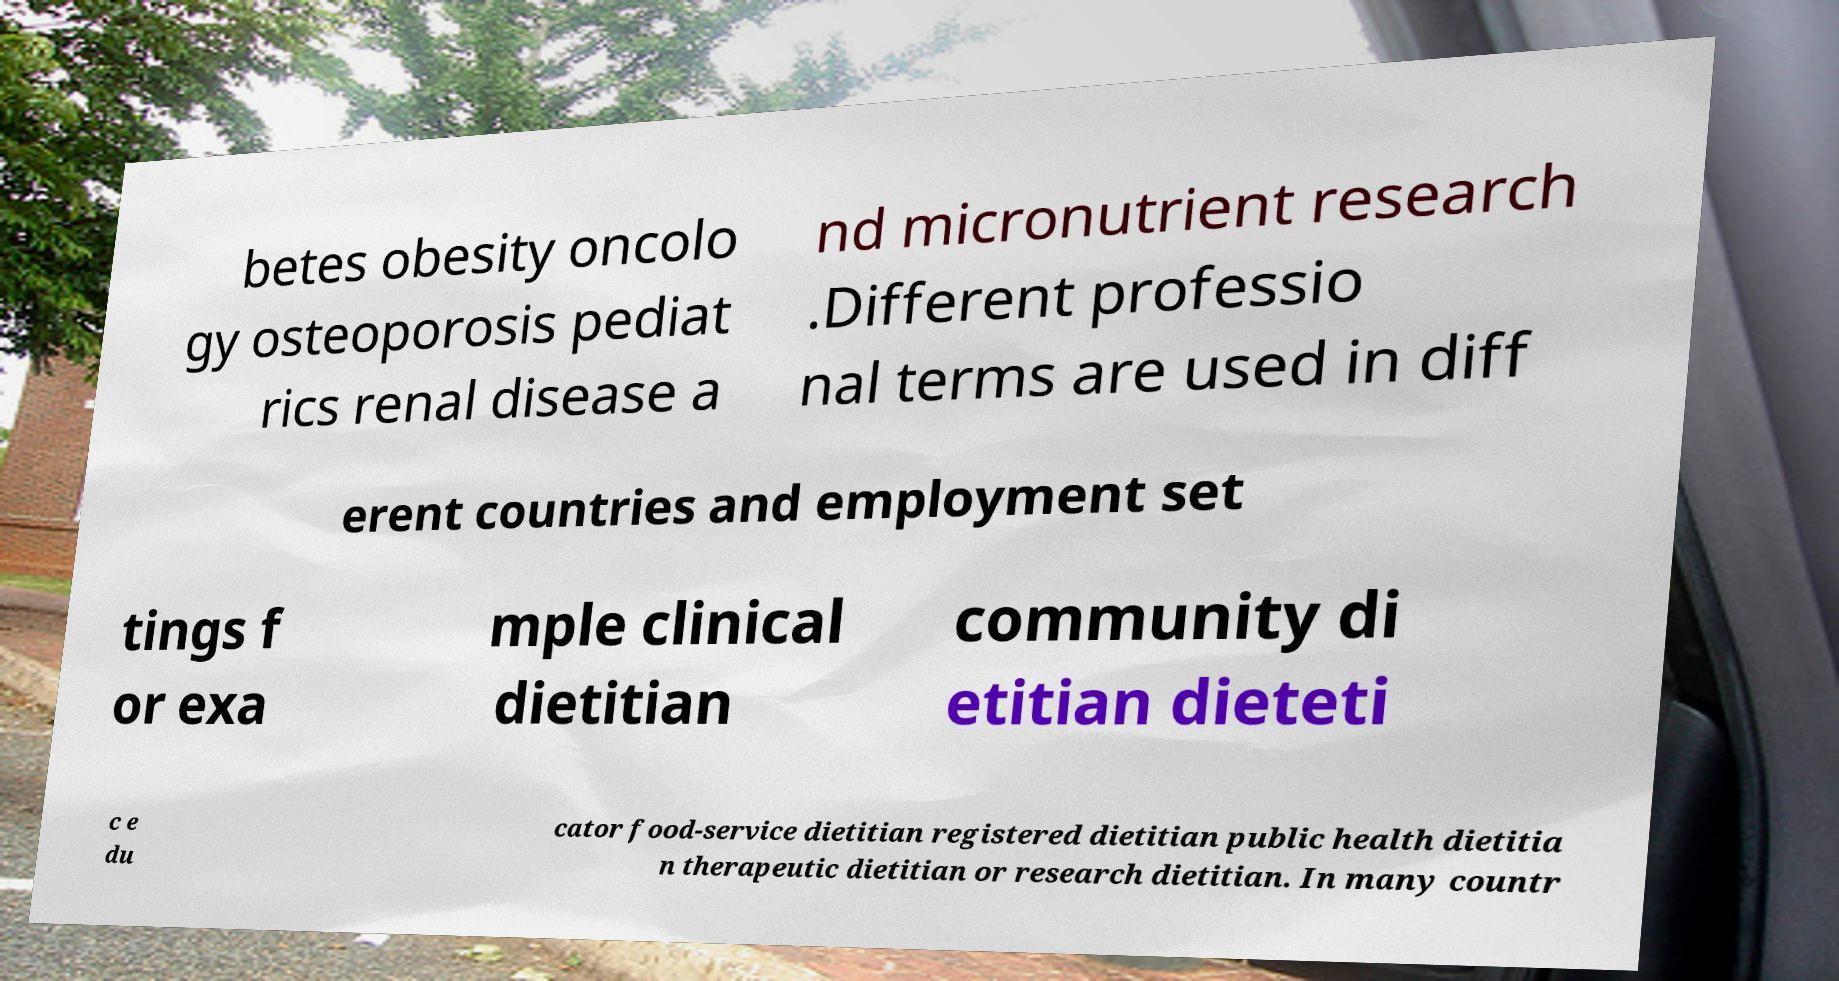Please read and relay the text visible in this image. What does it say? betes obesity oncolo gy osteoporosis pediat rics renal disease a nd micronutrient research .Different professio nal terms are used in diff erent countries and employment set tings f or exa mple clinical dietitian community di etitian dieteti c e du cator food-service dietitian registered dietitian public health dietitia n therapeutic dietitian or research dietitian. In many countr 